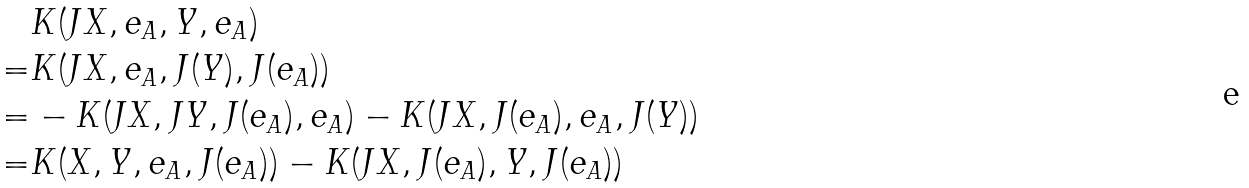<formula> <loc_0><loc_0><loc_500><loc_500>& K ( J X , e _ { A } , Y , e _ { A } ) \\ = & K ( J X , e _ { A } , J ( Y ) , J ( e _ { A } ) ) \\ = & - K ( J X , J Y , J ( e _ { A } ) , e _ { A } ) - K ( J X , J ( e _ { A } ) , e _ { A } , J ( Y ) ) \\ = & K ( X , Y , e _ { A } , J ( e _ { A } ) ) - K ( J X , J ( e _ { A } ) , Y , J ( e _ { A } ) ) \\</formula> 